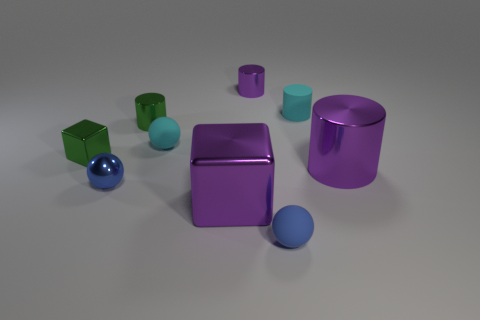Subtract all cubes. How many objects are left? 7 Subtract 0 brown cylinders. How many objects are left? 9 Subtract all big metallic objects. Subtract all cubes. How many objects are left? 5 Add 8 cyan matte things. How many cyan matte things are left? 10 Add 5 cyan rubber spheres. How many cyan rubber spheres exist? 6 